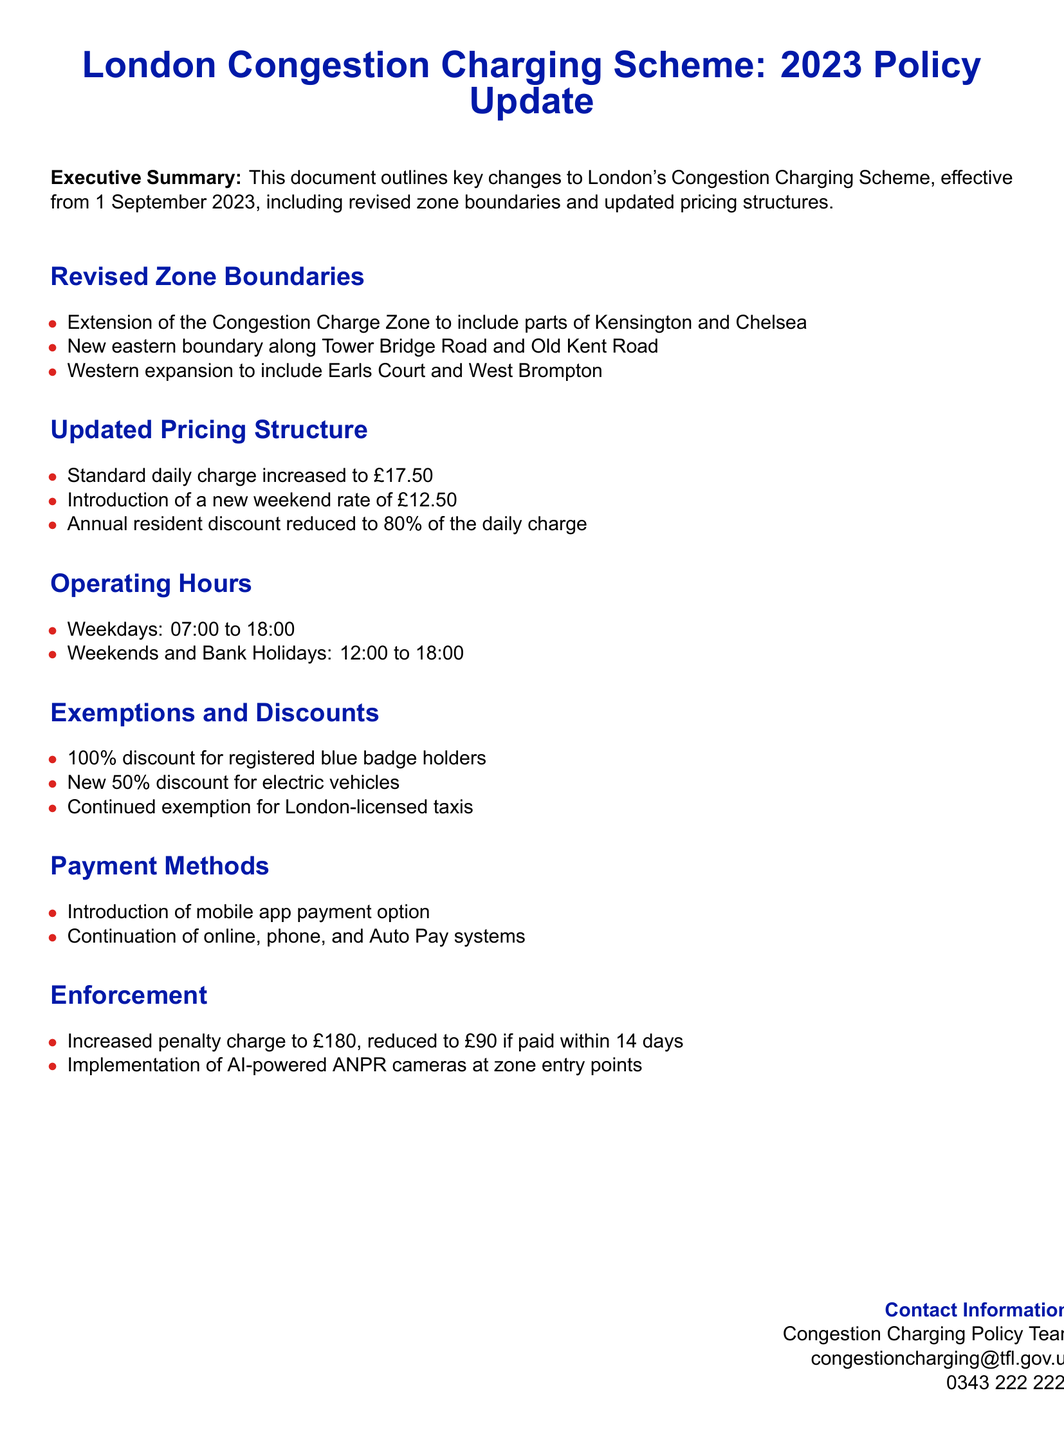What is the date of the policy update? The policy update is effective from 1 September 2023 as stated in the executive summary.
Answer: 1 September 2023 What is the new standard daily charge? The document states that the standard daily charge has been increased to £17.50.
Answer: £17.50 Which areas are newly included in the Congestion Charge Zone? The revised zone boundaries include Kensington and Chelsea, Earls Court, and West Brompton as mentioned in the revised zone boundaries section.
Answer: Kensington and Chelsea, Earls Court, West Brompton What is the weekend charging rate? The document specifies a new weekend rate of £12.50.
Answer: £12.50 What is the percentage of the annual resident discount? According to the updated pricing structure, the annual resident discount is reduced to 80% of the daily charge.
Answer: 80% What are the operating hours for weekends? The document mentions that the operating hours for weekends and bank holidays are from 12:00 to 18:00.
Answer: 12:00 to 18:00 What discount is offered for electric vehicles? A new 50% discount for electric vehicles is introduced as listed in the exemptions and discounts section.
Answer: 50% What is the increased penalty charge? The increased penalty charge has been stated as £180, which is reduced to £90 if paid within 14 days.
Answer: £180 What payment method is newly introduced? According to the payment methods section, a mobile app payment option has been introduced.
Answer: Mobile app payment option 